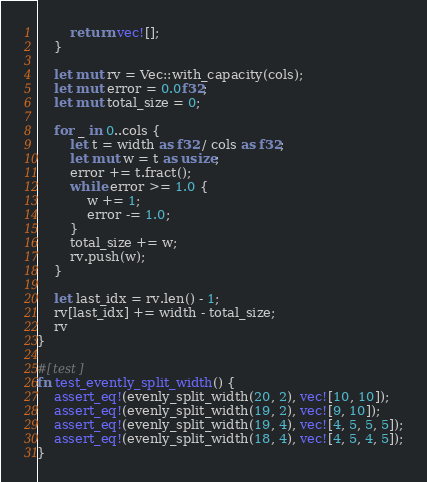<code> <loc_0><loc_0><loc_500><loc_500><_Rust_>        return vec![];
    }

    let mut rv = Vec::with_capacity(cols);
    let mut error = 0.0f32;
    let mut total_size = 0;

    for _ in 0..cols {
        let t = width as f32 / cols as f32;
        let mut w = t as usize;
        error += t.fract();
        while error >= 1.0 {
            w += 1;
            error -= 1.0;
        }
        total_size += w;
        rv.push(w);
    }

    let last_idx = rv.len() - 1;
    rv[last_idx] += width - total_size;
    rv
}

#[test]
fn test_evently_split_width() {
    assert_eq!(evenly_split_width(20, 2), vec![10, 10]);
    assert_eq!(evenly_split_width(19, 2), vec![9, 10]);
    assert_eq!(evenly_split_width(19, 4), vec![4, 5, 5, 5]);
    assert_eq!(evenly_split_width(18, 4), vec![4, 5, 4, 5]);
}
</code> 